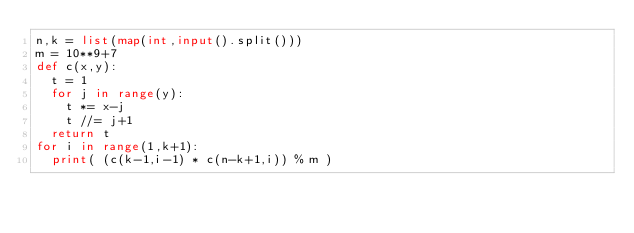Convert code to text. <code><loc_0><loc_0><loc_500><loc_500><_Python_>n,k = list(map(int,input().split()))
m = 10**9+7
def c(x,y):
  t = 1
  for j in range(y):
    t *= x-j
    t //= j+1
  return t
for i in range(1,k+1):
  print( (c(k-1,i-1) * c(n-k+1,i)) % m )</code> 